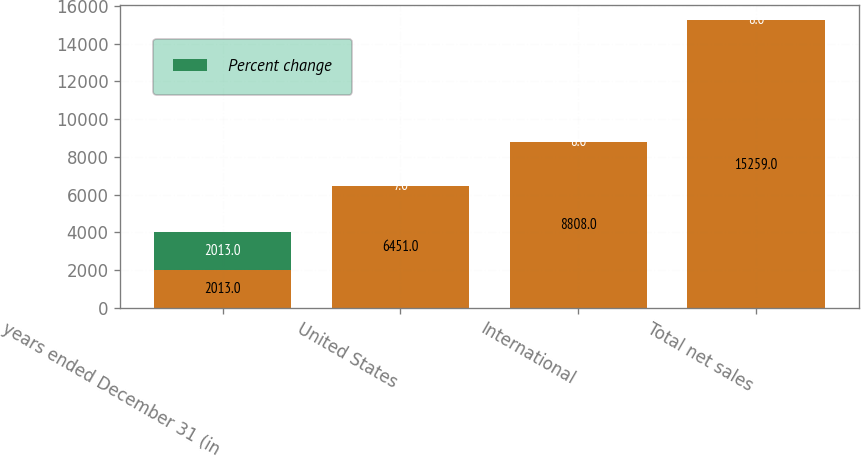Convert chart. <chart><loc_0><loc_0><loc_500><loc_500><stacked_bar_chart><ecel><fcel>years ended December 31 (in<fcel>United States<fcel>International<fcel>Total net sales<nl><fcel>nan<fcel>2013<fcel>6451<fcel>8808<fcel>15259<nl><fcel>Percent change<fcel>2013<fcel>7<fcel>8<fcel>8<nl></chart> 